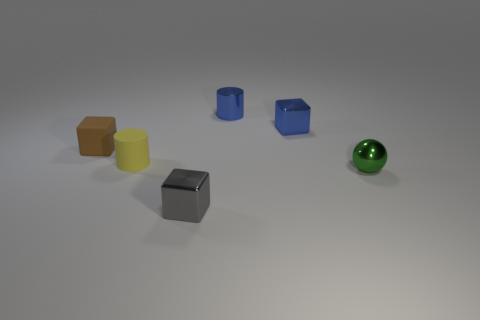Subtract all tiny brown blocks. How many blocks are left? 2 Add 2 large brown things. How many objects exist? 8 Subtract all balls. How many objects are left? 5 Subtract all blue cubes. How many cubes are left? 2 Add 3 brown blocks. How many brown blocks are left? 4 Add 4 metal cubes. How many metal cubes exist? 6 Subtract 0 yellow balls. How many objects are left? 6 Subtract 2 blocks. How many blocks are left? 1 Subtract all red cubes. Subtract all cyan cylinders. How many cubes are left? 3 Subtract all brown cubes. How many brown cylinders are left? 0 